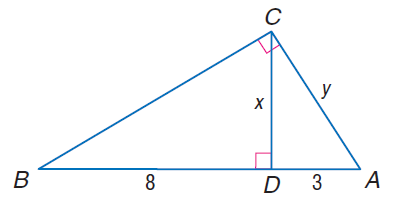Answer the mathemtical geometry problem and directly provide the correct option letter.
Question: Find x.
Choices: A: 2 \sqrt { 3 } B: 2 \sqrt { 6 } C: 4 \sqrt { 3 } D: 4 \sqrt { 6 } B 